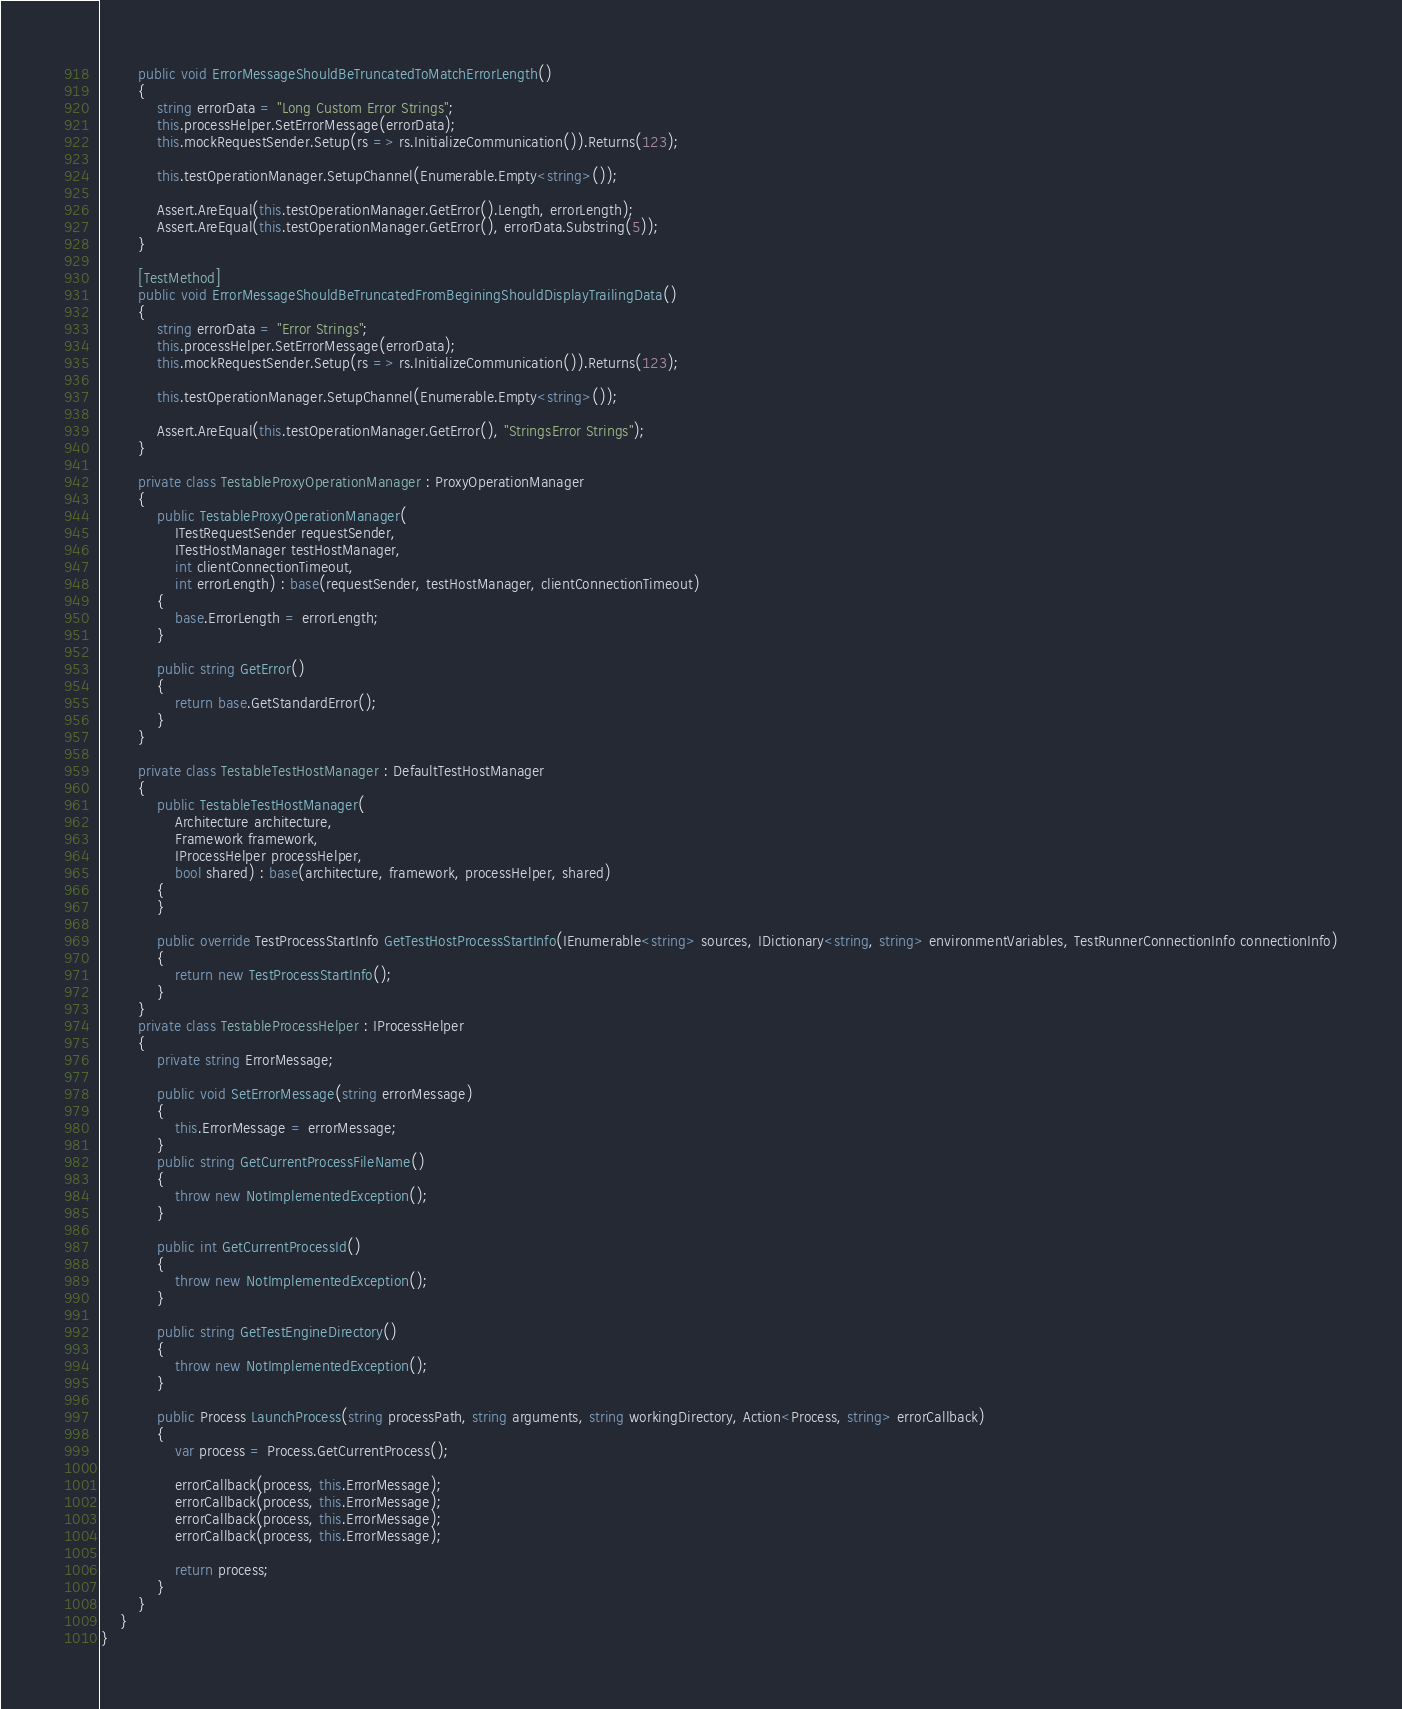<code> <loc_0><loc_0><loc_500><loc_500><_C#_>        public void ErrorMessageShouldBeTruncatedToMatchErrorLength()
        {
            string errorData = "Long Custom Error Strings";
            this.processHelper.SetErrorMessage(errorData);
            this.mockRequestSender.Setup(rs => rs.InitializeCommunication()).Returns(123);

            this.testOperationManager.SetupChannel(Enumerable.Empty<string>());

            Assert.AreEqual(this.testOperationManager.GetError().Length, errorLength);
            Assert.AreEqual(this.testOperationManager.GetError(), errorData.Substring(5));
        }

        [TestMethod]
        public void ErrorMessageShouldBeTruncatedFromBeginingShouldDisplayTrailingData()
        {
            string errorData = "Error Strings";
            this.processHelper.SetErrorMessage(errorData);
            this.mockRequestSender.Setup(rs => rs.InitializeCommunication()).Returns(123);

            this.testOperationManager.SetupChannel(Enumerable.Empty<string>());

            Assert.AreEqual(this.testOperationManager.GetError(), "StringsError Strings");
        }

        private class TestableProxyOperationManager : ProxyOperationManager
        {
            public TestableProxyOperationManager(
                ITestRequestSender requestSender,
                ITestHostManager testHostManager,
                int clientConnectionTimeout,
                int errorLength) : base(requestSender, testHostManager, clientConnectionTimeout)
            {
                base.ErrorLength = errorLength;
            }

            public string GetError()
            {
                return base.GetStandardError();
            }
        }

        private class TestableTestHostManager : DefaultTestHostManager
        {
            public TestableTestHostManager(
                Architecture architecture, 
                Framework framework, 
                IProcessHelper processHelper, 
                bool shared) : base(architecture, framework, processHelper, shared)
            {
            }

            public override TestProcessStartInfo GetTestHostProcessStartInfo(IEnumerable<string> sources, IDictionary<string, string> environmentVariables, TestRunnerConnectionInfo connectionInfo)
            {
                return new TestProcessStartInfo();
            }
        }
        private class TestableProcessHelper : IProcessHelper
        {
            private string ErrorMessage;

            public void SetErrorMessage(string errorMessage)
            {
                this.ErrorMessage = errorMessage;
            }
            public string GetCurrentProcessFileName()
            {
                throw new NotImplementedException();
            }

            public int GetCurrentProcessId()
            {
                throw new NotImplementedException();
            }

            public string GetTestEngineDirectory()
            {
                throw new NotImplementedException();
            }

            public Process LaunchProcess(string processPath, string arguments, string workingDirectory, Action<Process, string> errorCallback)
            {
                var process = Process.GetCurrentProcess();

                errorCallback(process, this.ErrorMessage);
                errorCallback(process, this.ErrorMessage);
                errorCallback(process, this.ErrorMessage);
                errorCallback(process, this.ErrorMessage);
                
                return process;
            }
        }
    }
}
</code> 